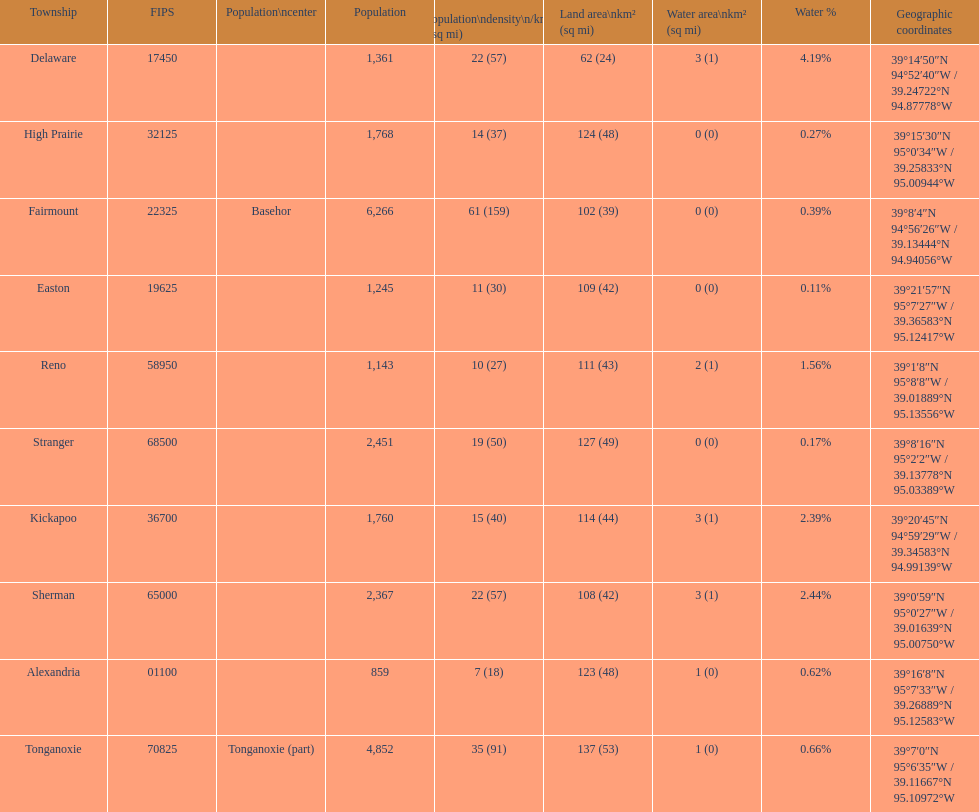Was delaware's land area above or below 45 square miles? Above. 